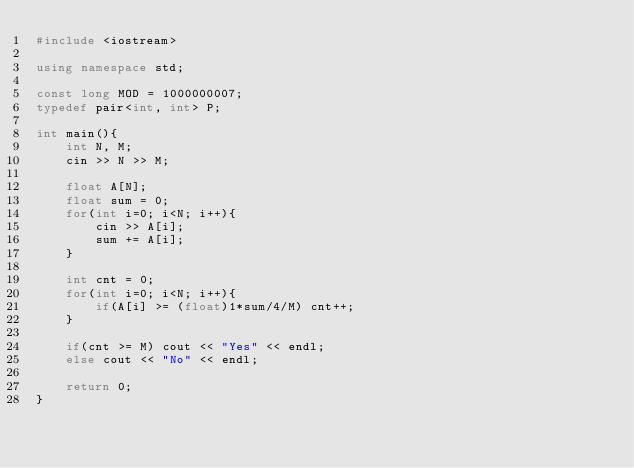Convert code to text. <code><loc_0><loc_0><loc_500><loc_500><_C++_>#include <iostream>

using namespace std;

const long MOD = 1000000007;
typedef pair<int, int> P;

int main(){
    int N, M;
    cin >> N >> M;

    float A[N];
    float sum = 0;
    for(int i=0; i<N; i++){
        cin >> A[i];
        sum += A[i];
    }

    int cnt = 0;
    for(int i=0; i<N; i++){
        if(A[i] >= (float)1*sum/4/M) cnt++;
    }

    if(cnt >= M) cout << "Yes" << endl;
    else cout << "No" << endl;

    return 0;
}
</code> 